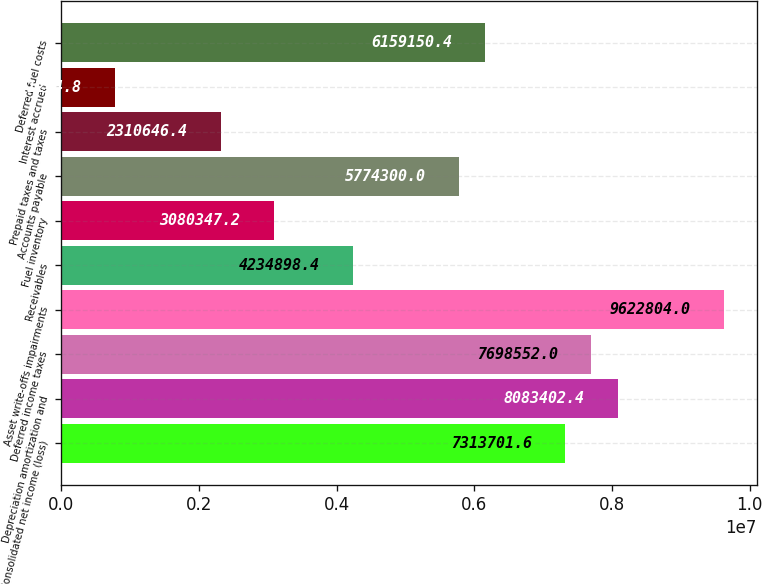Convert chart to OTSL. <chart><loc_0><loc_0><loc_500><loc_500><bar_chart><fcel>Consolidated net income (loss)<fcel>Depreciation amortization and<fcel>Deferred income taxes<fcel>Asset write-offs impairments<fcel>Receivables<fcel>Fuel inventory<fcel>Accounts payable<fcel>Prepaid taxes and taxes<fcel>Interest accrued<fcel>Deferred fuel costs<nl><fcel>7.3137e+06<fcel>8.0834e+06<fcel>7.69855e+06<fcel>9.6228e+06<fcel>4.2349e+06<fcel>3.08035e+06<fcel>5.7743e+06<fcel>2.31065e+06<fcel>771245<fcel>6.15915e+06<nl></chart> 